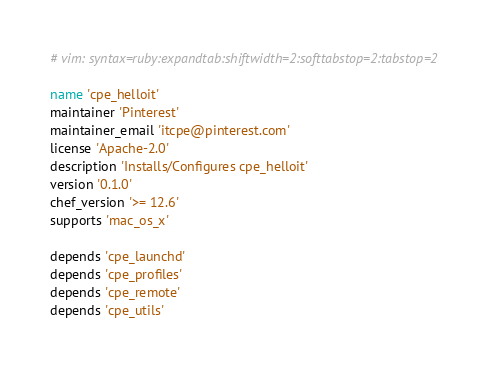Convert code to text. <code><loc_0><loc_0><loc_500><loc_500><_Ruby_># vim: syntax=ruby:expandtab:shiftwidth=2:softtabstop=2:tabstop=2

name 'cpe_helloit'
maintainer 'Pinterest'
maintainer_email 'itcpe@pinterest.com'
license 'Apache-2.0'
description 'Installs/Configures cpe_helloit'
version '0.1.0'
chef_version '>= 12.6'
supports 'mac_os_x'

depends 'cpe_launchd'
depends 'cpe_profiles'
depends 'cpe_remote'
depends 'cpe_utils'
</code> 